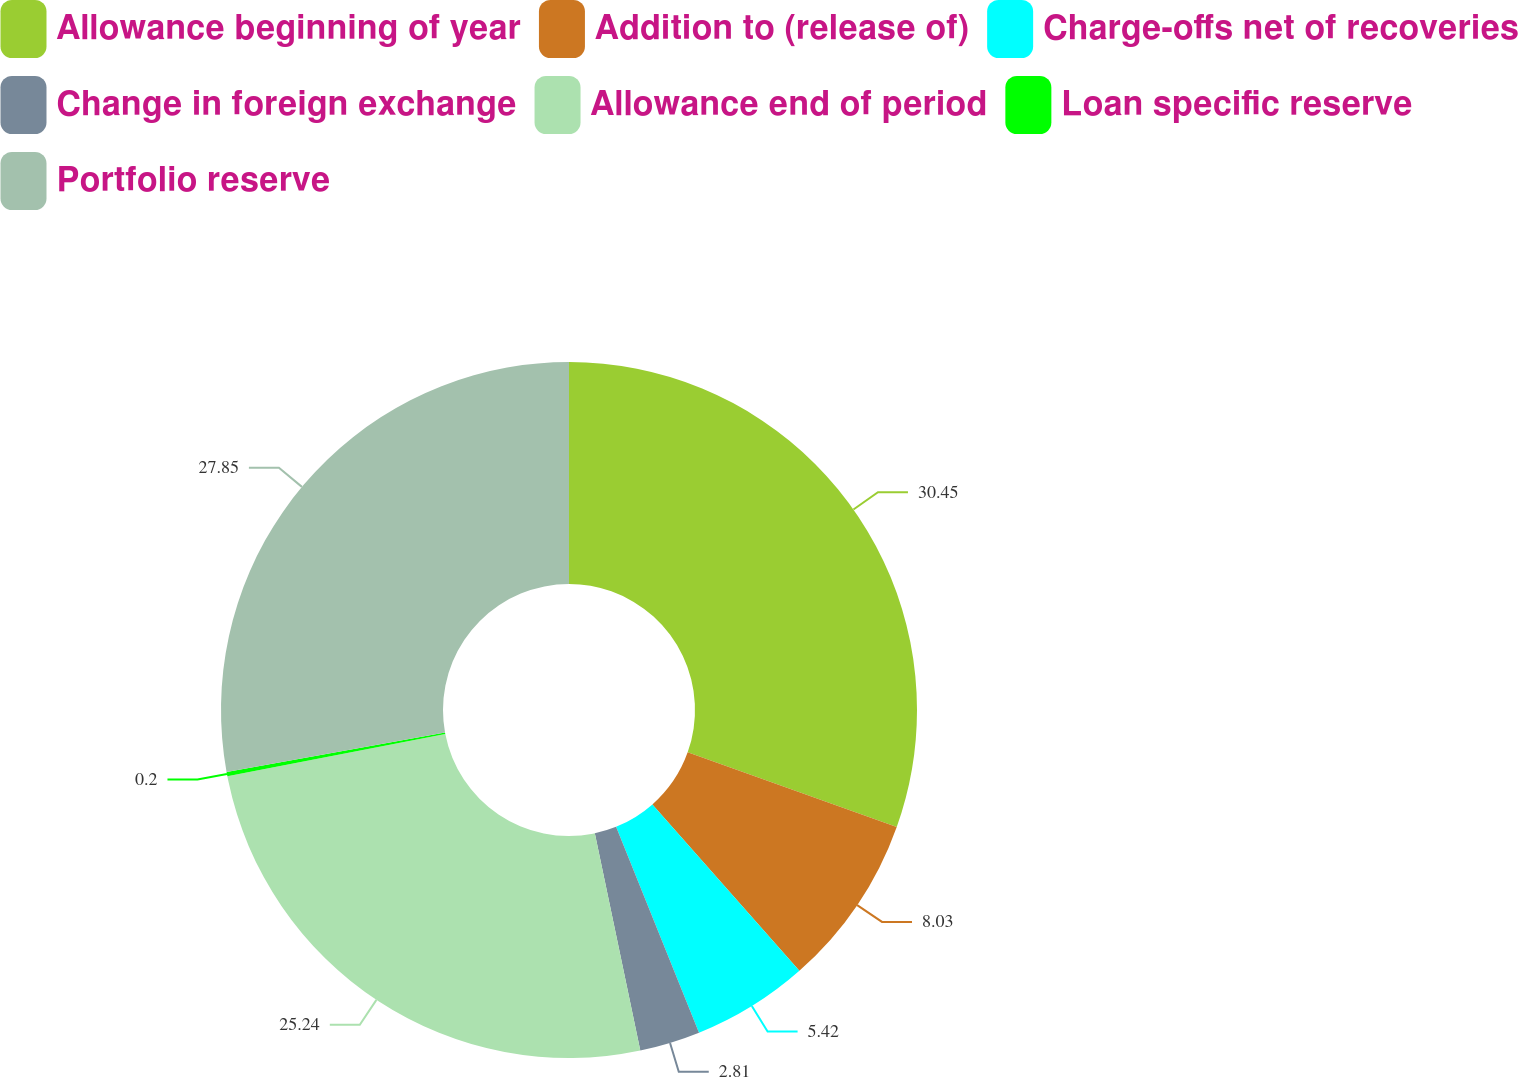<chart> <loc_0><loc_0><loc_500><loc_500><pie_chart><fcel>Allowance beginning of year<fcel>Addition to (release of)<fcel>Charge-offs net of recoveries<fcel>Change in foreign exchange<fcel>Allowance end of period<fcel>Loan specific reserve<fcel>Portfolio reserve<nl><fcel>30.46%<fcel>8.03%<fcel>5.42%<fcel>2.81%<fcel>25.24%<fcel>0.2%<fcel>27.85%<nl></chart> 